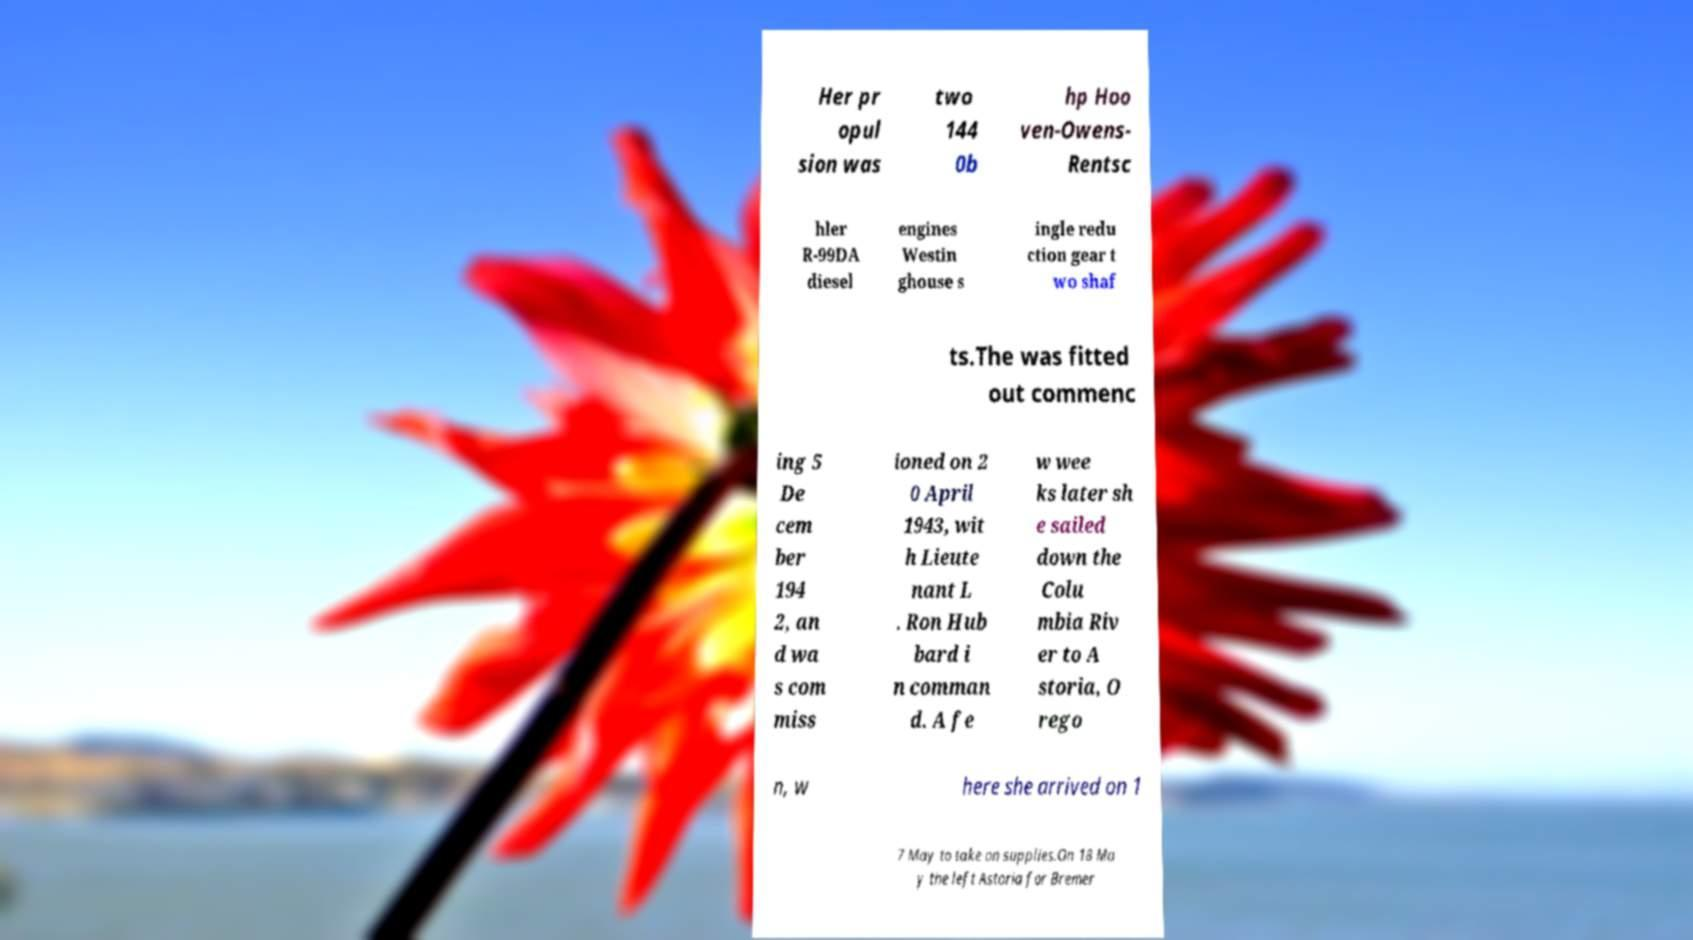Please identify and transcribe the text found in this image. Her pr opul sion was two 144 0b hp Hoo ven-Owens- Rentsc hler R-99DA diesel engines Westin ghouse s ingle redu ction gear t wo shaf ts.The was fitted out commenc ing 5 De cem ber 194 2, an d wa s com miss ioned on 2 0 April 1943, wit h Lieute nant L . Ron Hub bard i n comman d. A fe w wee ks later sh e sailed down the Colu mbia Riv er to A storia, O rego n, w here she arrived on 1 7 May to take on supplies.On 18 Ma y the left Astoria for Bremer 